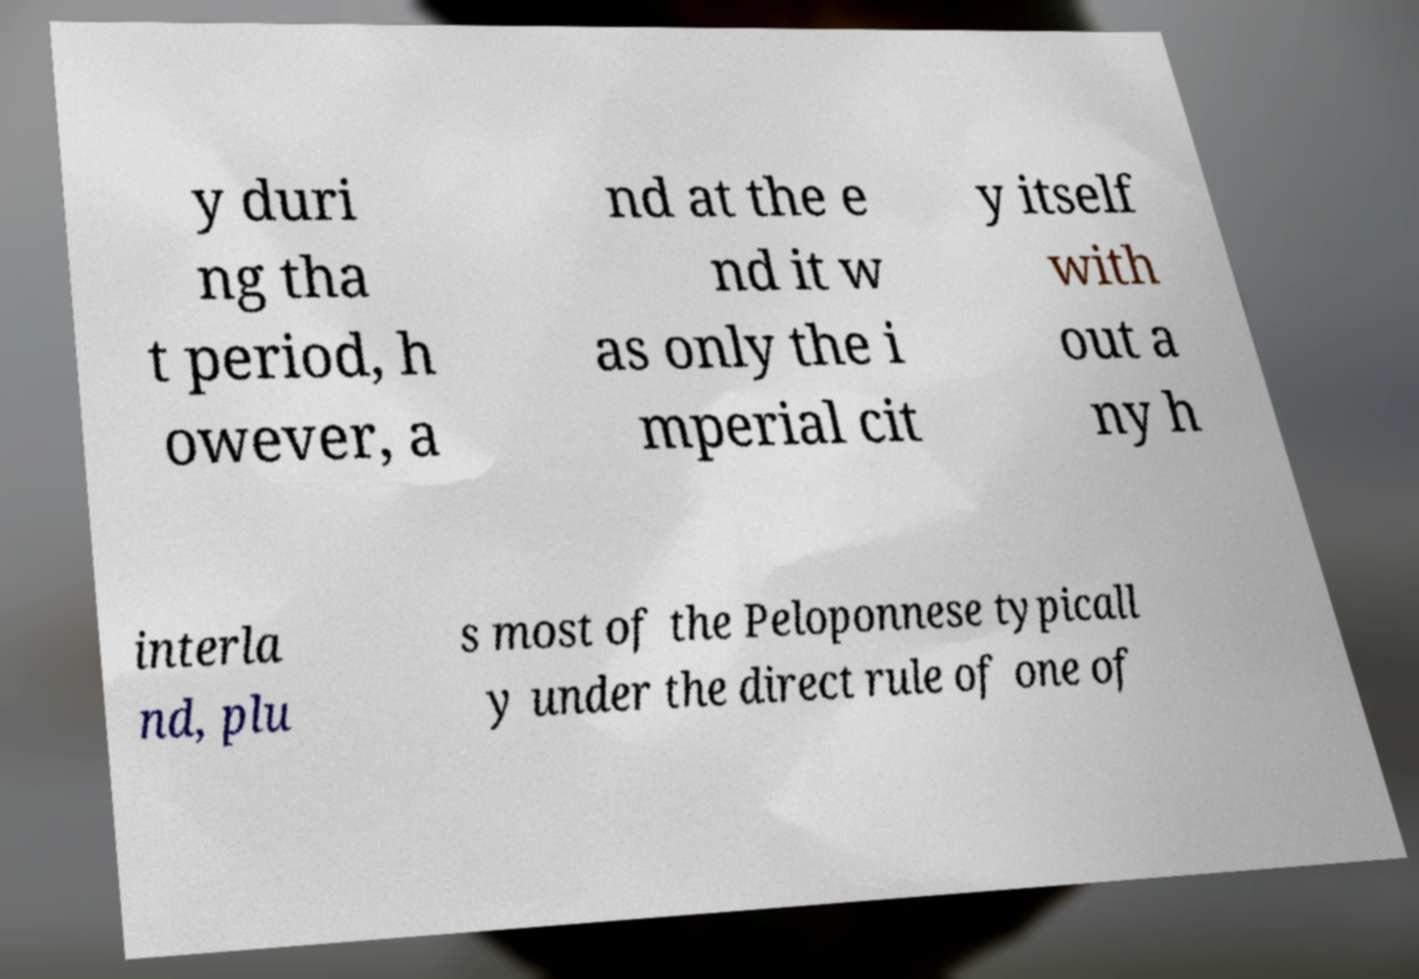Please identify and transcribe the text found in this image. y duri ng tha t period, h owever, a nd at the e nd it w as only the i mperial cit y itself with out a ny h interla nd, plu s most of the Peloponnese typicall y under the direct rule of one of 